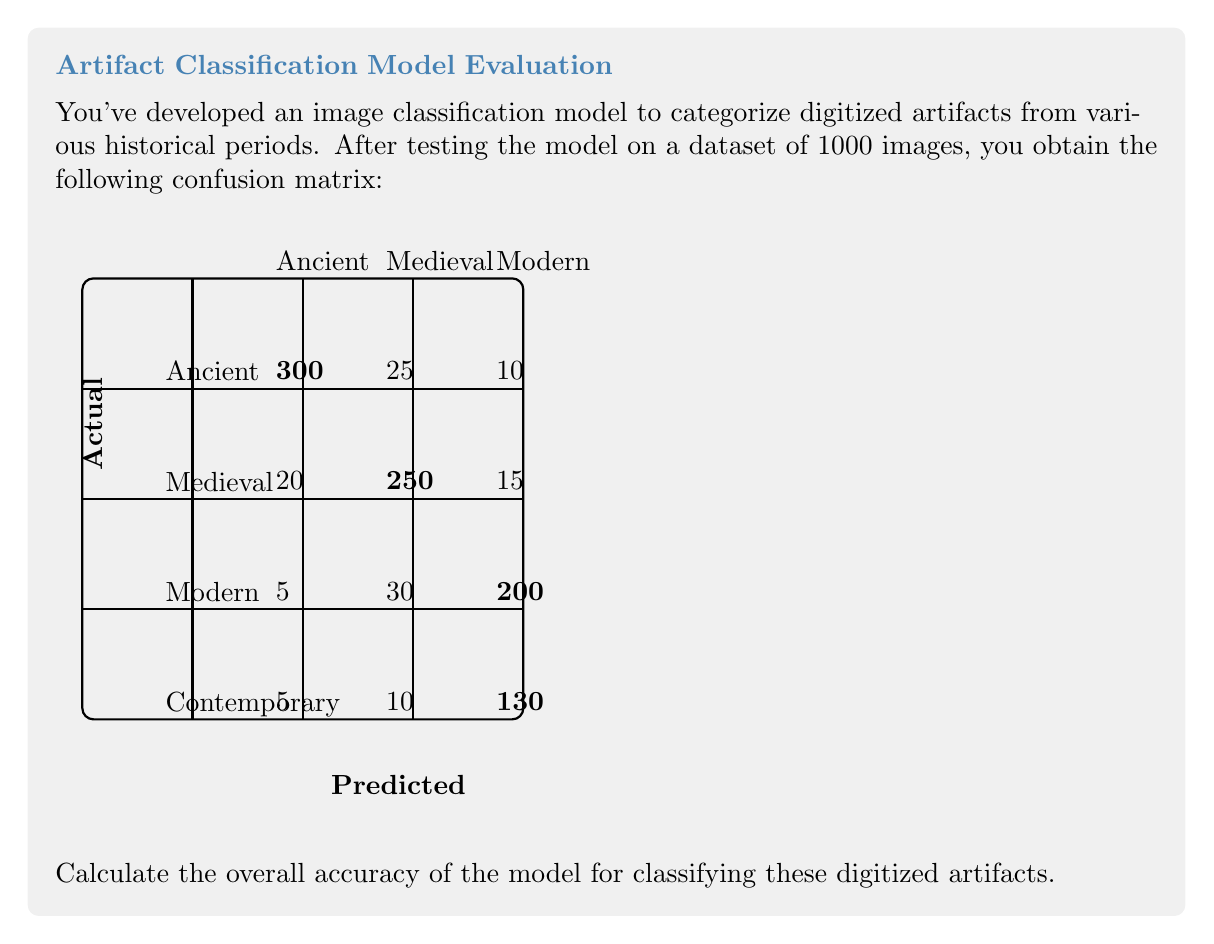Help me with this question. To calculate the overall accuracy of the image classification model, we need to follow these steps:

1) First, let's understand what the confusion matrix represents:
   - The diagonal elements represent correct classifications
   - Off-diagonal elements represent misclassifications

2) Calculate the total number of correct predictions:
   Ancient: 300
   Medieval: 250
   Modern: 200
   Contemporary: 130
   
   Total correct = 300 + 250 + 200 + 130 = 880

3) Calculate the total number of predictions:
   Sum of all elements in the confusion matrix = 1000

4) The accuracy is defined as:

   $$ \text{Accuracy} = \frac{\text{Number of correct predictions}}{\text{Total number of predictions}} $$

5) Substituting our values:

   $$ \text{Accuracy} = \frac{880}{1000} = 0.88 $$

6) Convert to percentage:
   0.88 * 100 = 88%

Therefore, the overall accuracy of the model for classifying these digitized artifacts is 88%.
Answer: 88% 